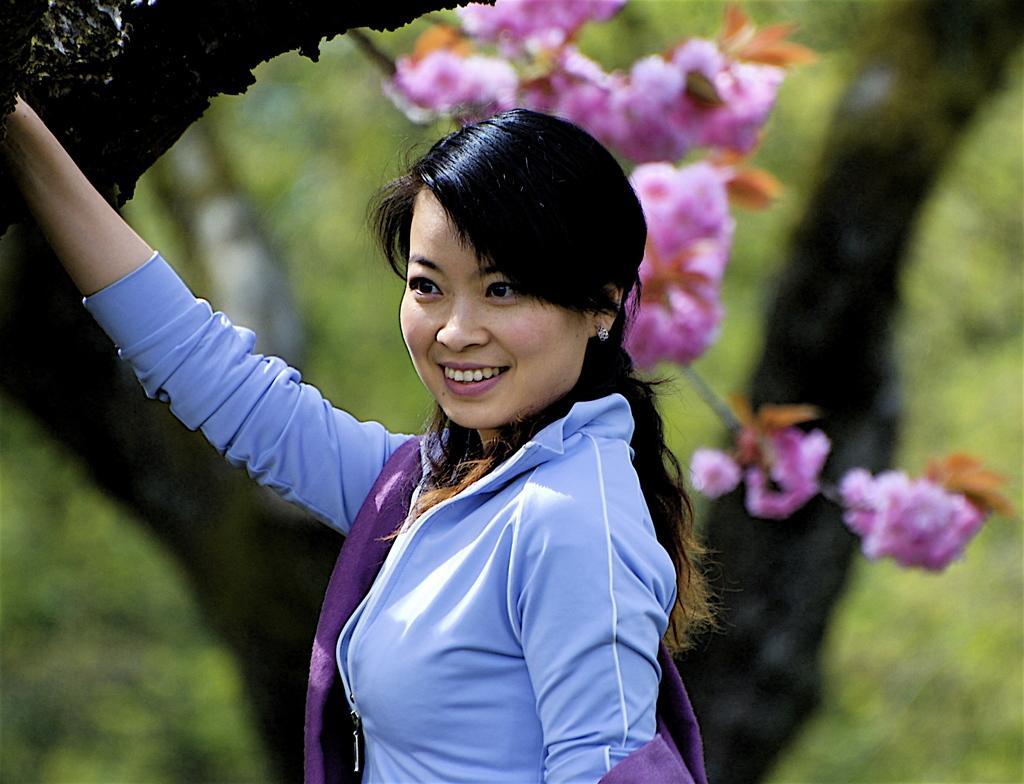Please provide a concise description of this image. This is the woman standing and smiling. I think these are the flowers with the stem. This looks like a tree trunk. The background looks blurry. 